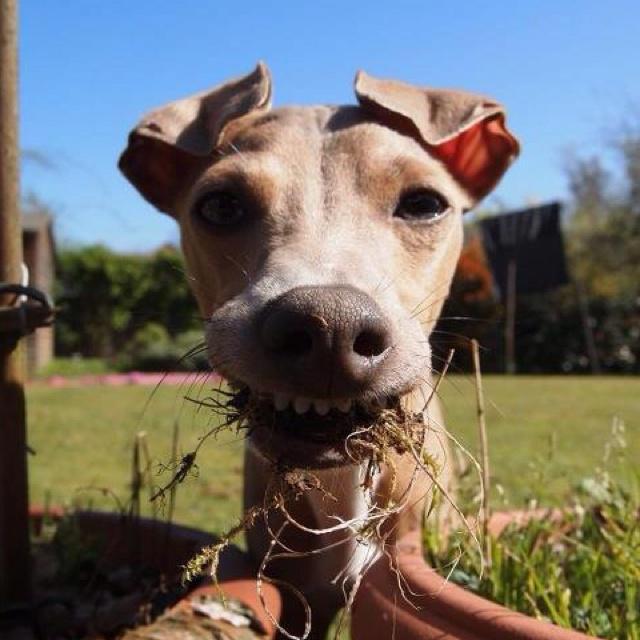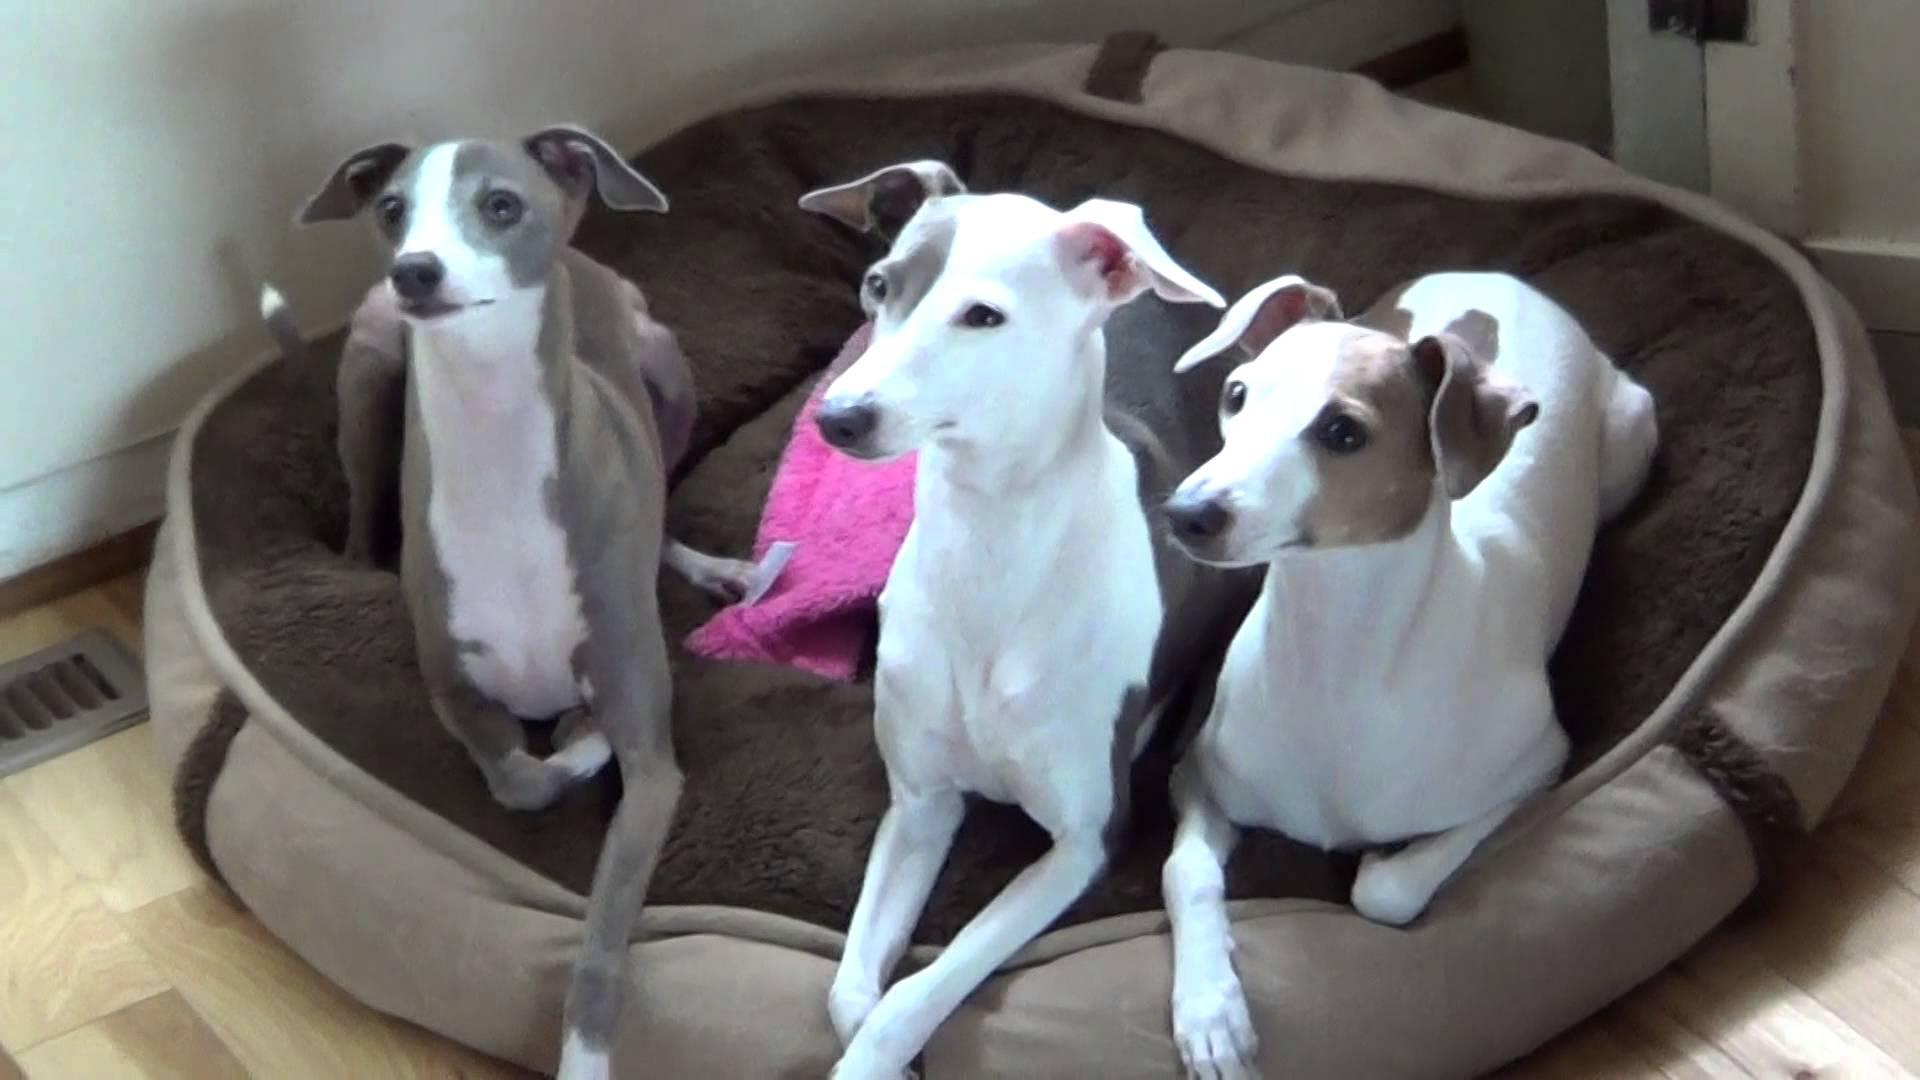The first image is the image on the left, the second image is the image on the right. Given the left and right images, does the statement "There are more dogs in the right image than in the left." hold true? Answer yes or no. Yes. The first image is the image on the left, the second image is the image on the right. Considering the images on both sides, is "Several hounds are resting together on something manmade, neutral-colored and plush." valid? Answer yes or no. Yes. The first image is the image on the left, the second image is the image on the right. Evaluate the accuracy of this statement regarding the images: "In one image, a dog is being cradled in a person's arm.". Is it true? Answer yes or no. No. The first image is the image on the left, the second image is the image on the right. Considering the images on both sides, is "The right image contains no more than one dog." valid? Answer yes or no. No. 